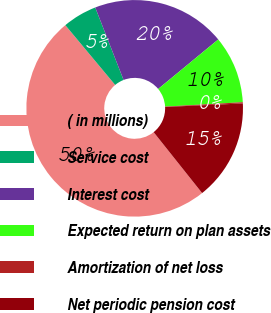Convert chart to OTSL. <chart><loc_0><loc_0><loc_500><loc_500><pie_chart><fcel>( in millions)<fcel>Service cost<fcel>Interest cost<fcel>Expected return on plan assets<fcel>Amortization of net loss<fcel>Net periodic pension cost<nl><fcel>49.63%<fcel>5.13%<fcel>19.96%<fcel>10.07%<fcel>0.18%<fcel>15.02%<nl></chart> 